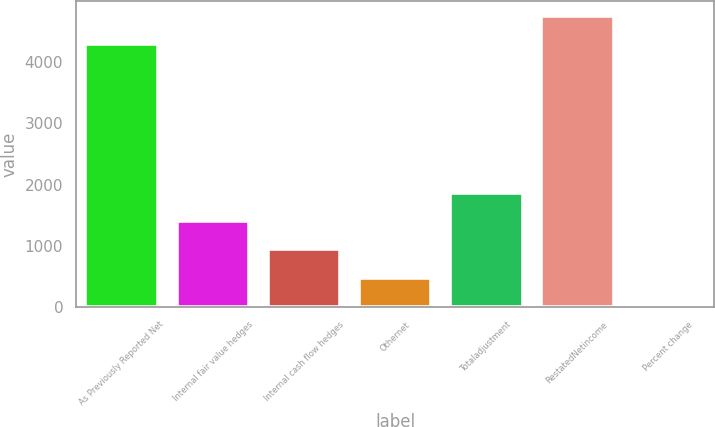<chart> <loc_0><loc_0><loc_500><loc_500><bar_chart><fcel>As Previously Reported Net<fcel>Internal fair value hedges<fcel>Internal cash flow hedges<fcel>Othernet<fcel>Totaladjustment<fcel>RestatedNetincome<fcel>Percent change<nl><fcel>4296<fcel>1402.98<fcel>938.12<fcel>473.26<fcel>1867.84<fcel>4760.86<fcel>8.4<nl></chart> 